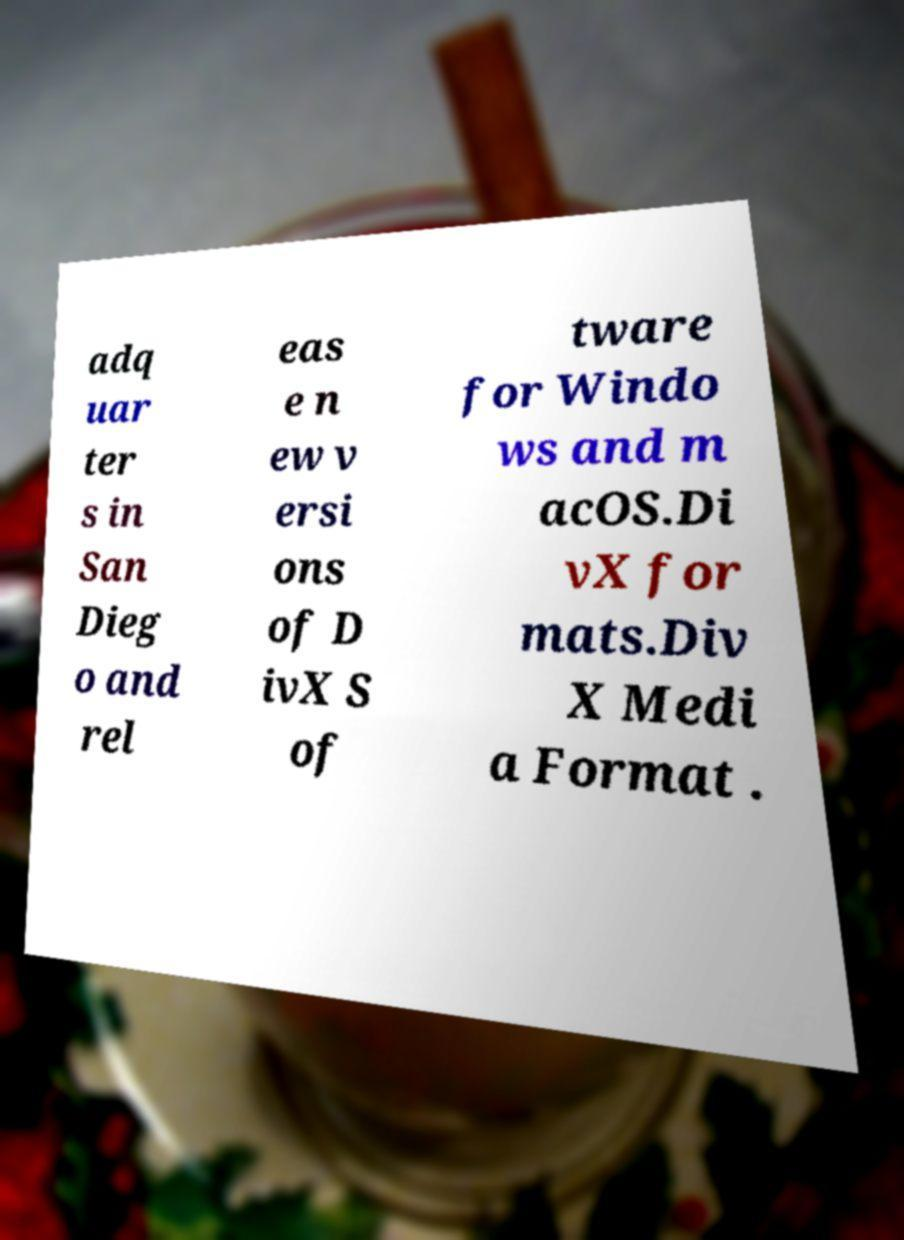I need the written content from this picture converted into text. Can you do that? adq uar ter s in San Dieg o and rel eas e n ew v ersi ons of D ivX S of tware for Windo ws and m acOS.Di vX for mats.Div X Medi a Format . 